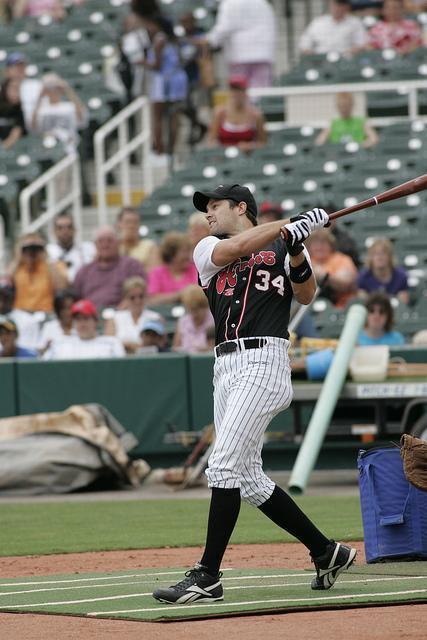How many people are visible?
Give a very brief answer. 10. 